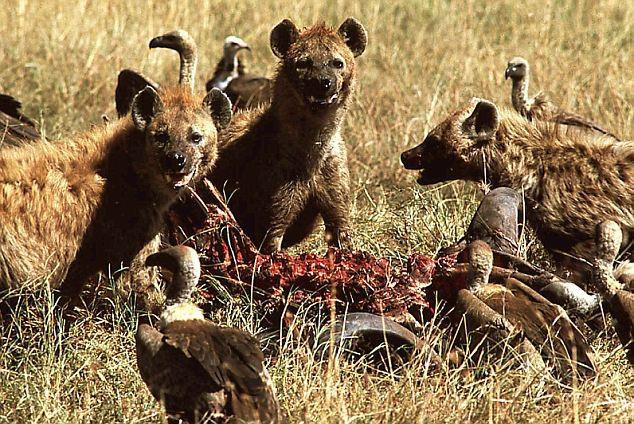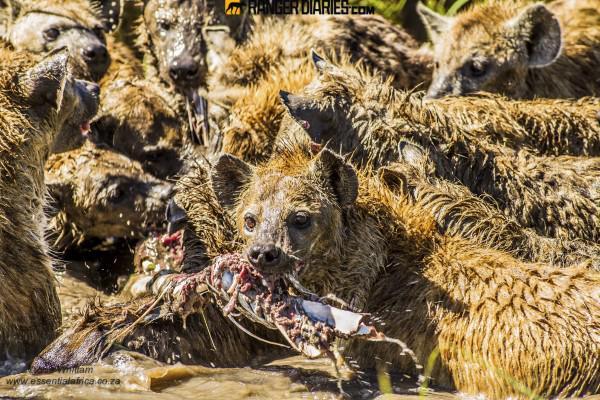The first image is the image on the left, the second image is the image on the right. Analyze the images presented: Is the assertion "Some of the animals are eating their prey." valid? Answer yes or no. Yes. The first image is the image on the left, the second image is the image on the right. Evaluate the accuracy of this statement regarding the images: "At least one image shows hyenas around an animal carcass.". Is it true? Answer yes or no. Yes. 